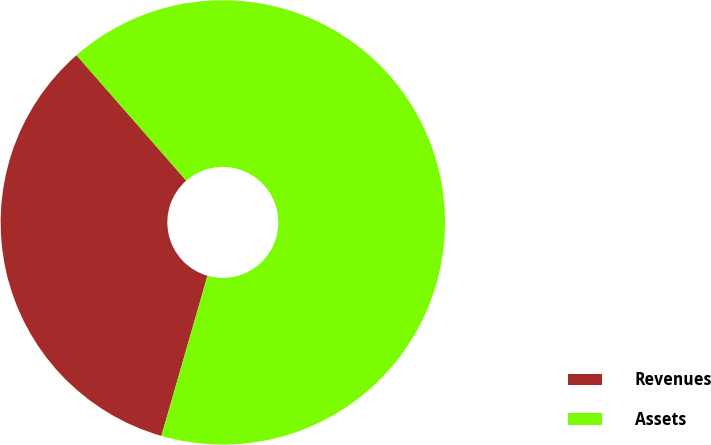Convert chart. <chart><loc_0><loc_0><loc_500><loc_500><pie_chart><fcel>Revenues<fcel>Assets<nl><fcel>34.1%<fcel>65.9%<nl></chart> 